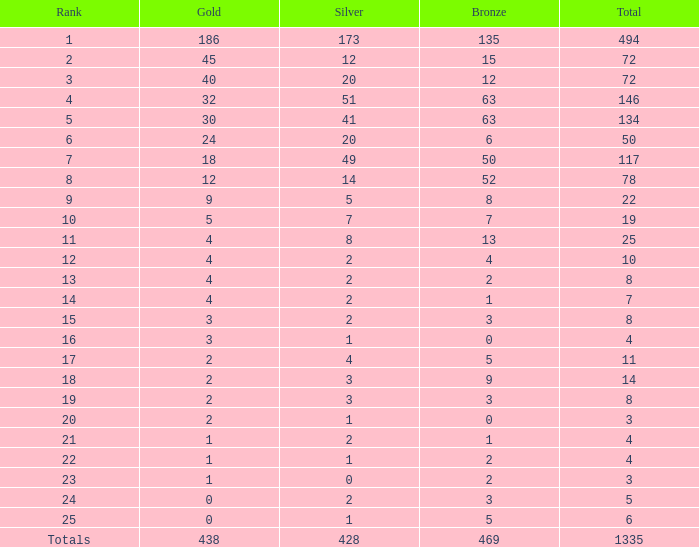What is the total amount of gold medals when there were more than 20 silvers and there were 135 bronze medals? 1.0. 